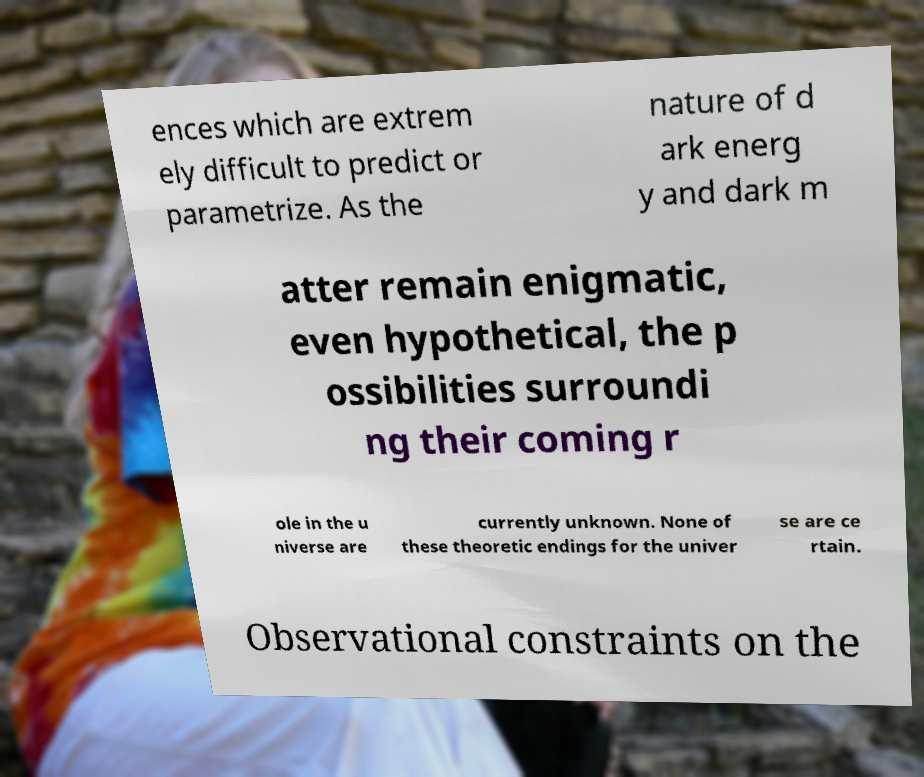What messages or text are displayed in this image? I need them in a readable, typed format. ences which are extrem ely difficult to predict or parametrize. As the nature of d ark energ y and dark m atter remain enigmatic, even hypothetical, the p ossibilities surroundi ng their coming r ole in the u niverse are currently unknown. None of these theoretic endings for the univer se are ce rtain. Observational constraints on the 